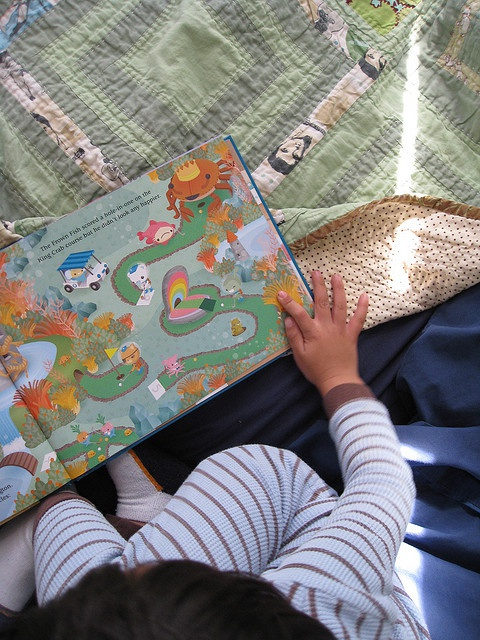Describe the objects in this image and their specific colors. I can see bed in gray, darkgray, and lightgray tones, book in gray, darkgray, and green tones, people in gray, black, darkgray, and lavender tones, and bed in gray, black, navy, blue, and darkblue tones in this image. 